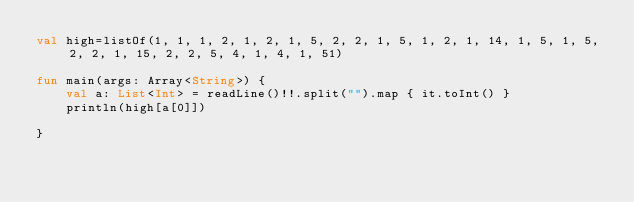<code> <loc_0><loc_0><loc_500><loc_500><_Kotlin_>val high=listOf(1, 1, 1, 2, 1, 2, 1, 5, 2, 2, 1, 5, 1, 2, 1, 14, 1, 5, 1, 5, 2, 2, 1, 15, 2, 2, 5, 4, 1, 4, 1, 51)

fun main(args: Array<String>) {
    val a: List<Int> = readLine()!!.split("").map { it.toInt() }
    println(high[a[0]])

}

</code> 